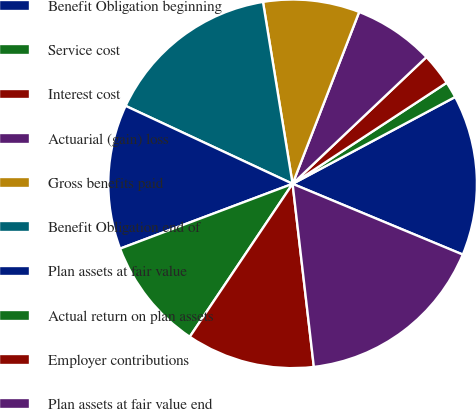Convert chart. <chart><loc_0><loc_0><loc_500><loc_500><pie_chart><fcel>Benefit Obligation beginning<fcel>Service cost<fcel>Interest cost<fcel>Actuarial (gain) loss<fcel>Gross benefits paid<fcel>Benefit Obligation end of<fcel>Plan assets at fair value<fcel>Actual return on plan assets<fcel>Employer contributions<fcel>Plan assets at fair value end<nl><fcel>14.08%<fcel>1.43%<fcel>2.83%<fcel>7.05%<fcel>8.45%<fcel>15.48%<fcel>12.67%<fcel>9.86%<fcel>11.26%<fcel>16.89%<nl></chart> 